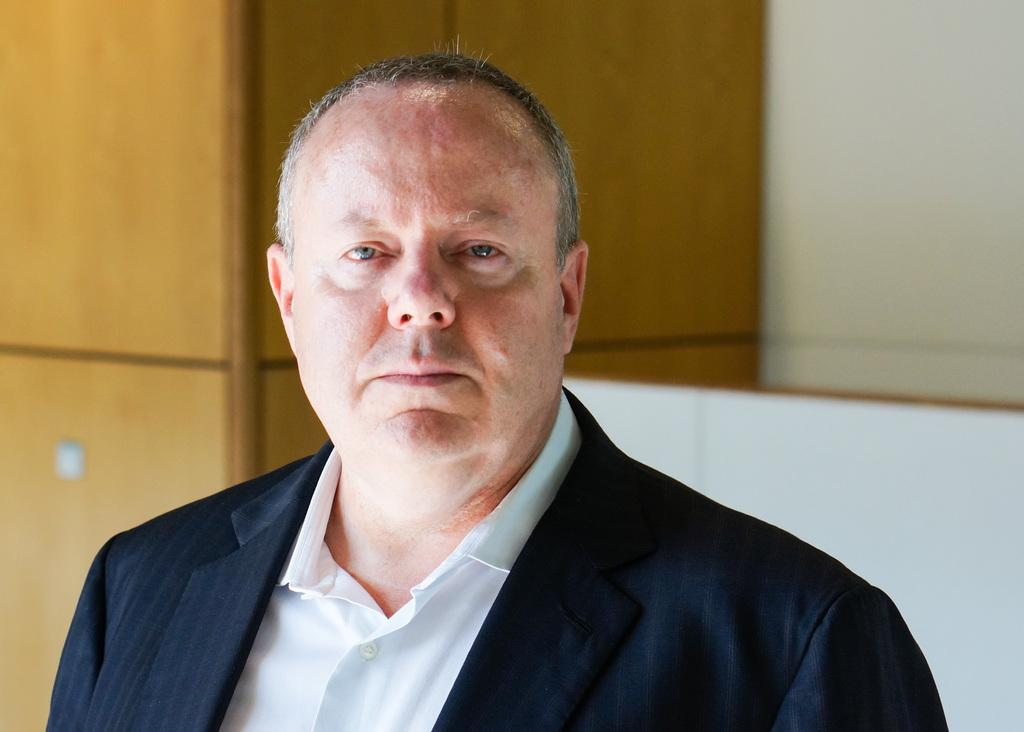Where was the image taken? The image is taken indoors. What can be seen in the background of the image? There is a wall in the background of the image. Who is the main subject in the image? There is a man in the middle of the image. What is the man wearing? The man is wearing a suit and a white shirt. What type of copper object is being used in the competition in the image? There is no copper object or competition present in the image. 